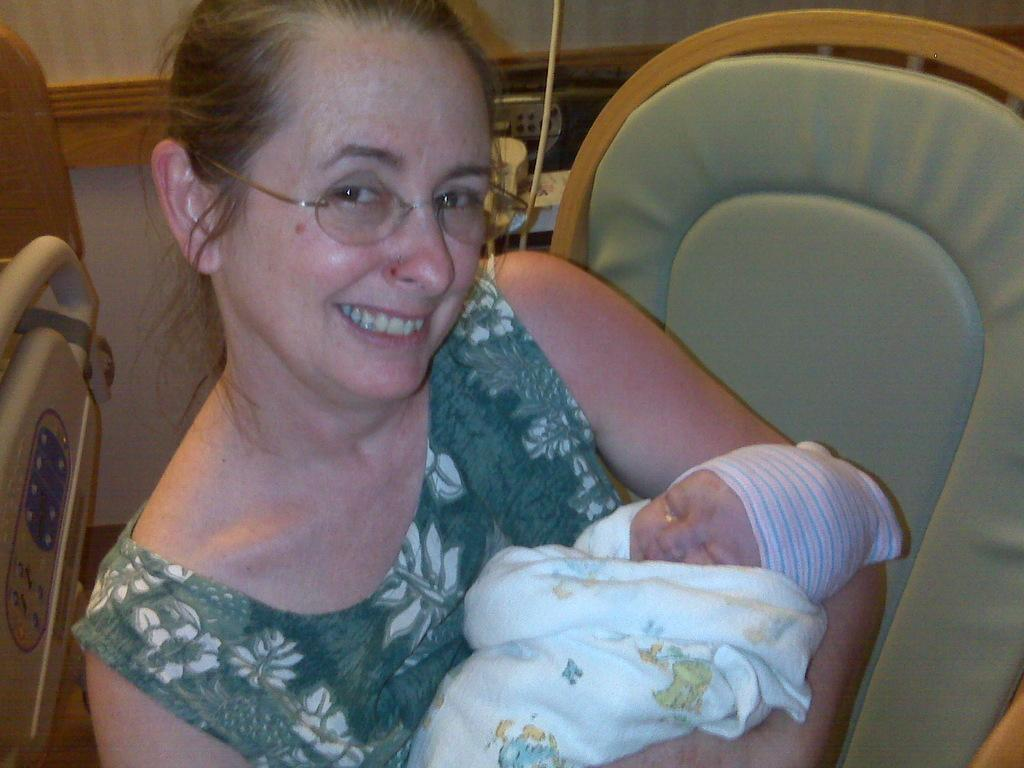Who is the main subject in the image? There is a lady in the image. What is the lady doing in the image? The lady is sitting on a chair and holding a baby. What is the lady's facial expression in the image? The lady has a smile on her face. What is the purpose of the stretcher beside the lady? The purpose of the stretcher is not clear from the image, but it might be related to the baby or the lady. What can be seen behind the lady in the image? There are objects visible behind the lady, but their specific nature is not clear from the facts provided. What type of produce can be seen on the side of the store in the image? There is no store or produce present in the image; it features a lady sitting on a chair holding a baby. 